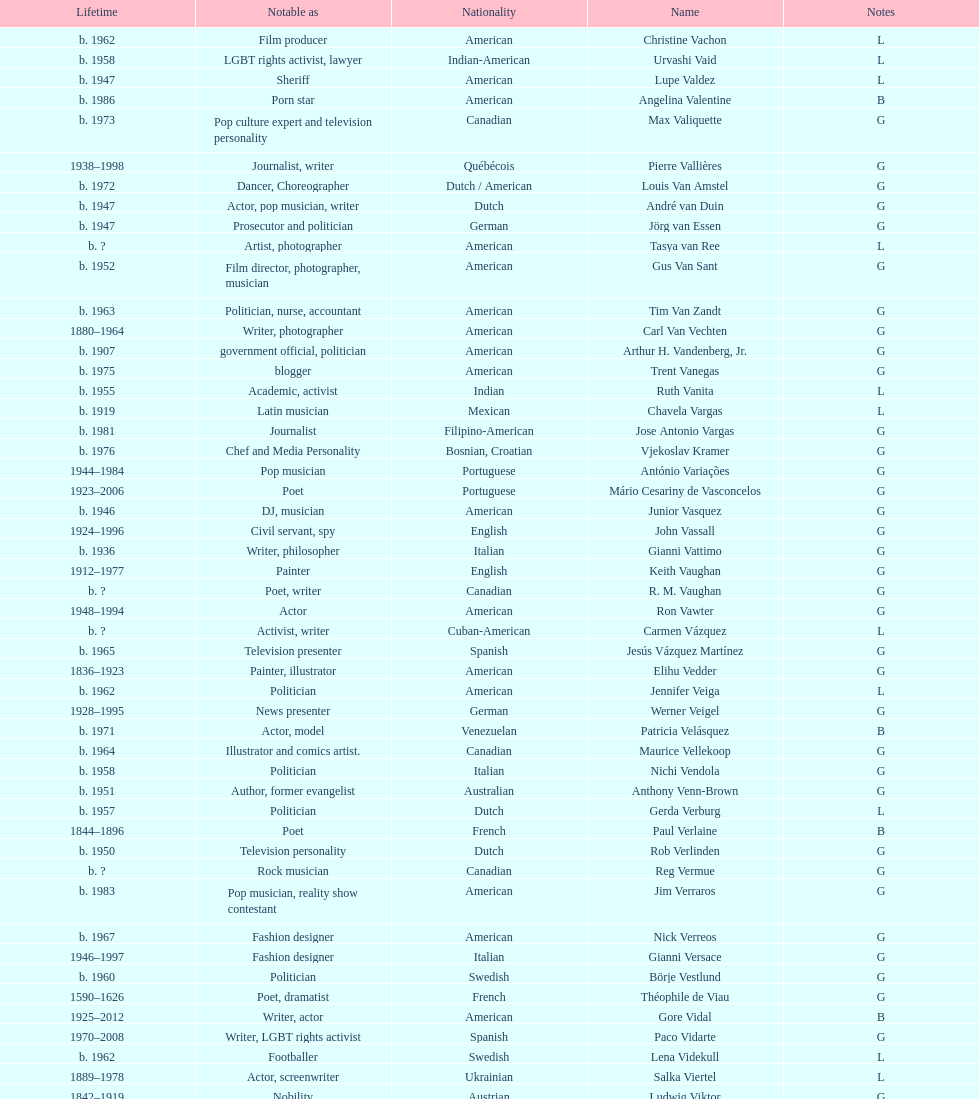Which nationality had the larger amount of names listed? American. 